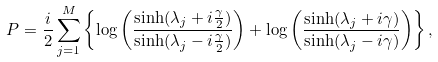Convert formula to latex. <formula><loc_0><loc_0><loc_500><loc_500>P = \frac { i } { 2 } \sum _ { j = 1 } ^ { M } \left \{ \log \left ( \frac { \sinh ( \lambda _ { j } + i \frac { \gamma } { 2 } ) } { \sinh ( \lambda _ { j } - i \frac { \gamma } { 2 } ) } \right ) + \log \left ( \frac { \sinh ( \lambda _ { j } + i \gamma ) } { \sinh ( \lambda _ { j } - i \gamma ) } \right ) \right \} ,</formula> 